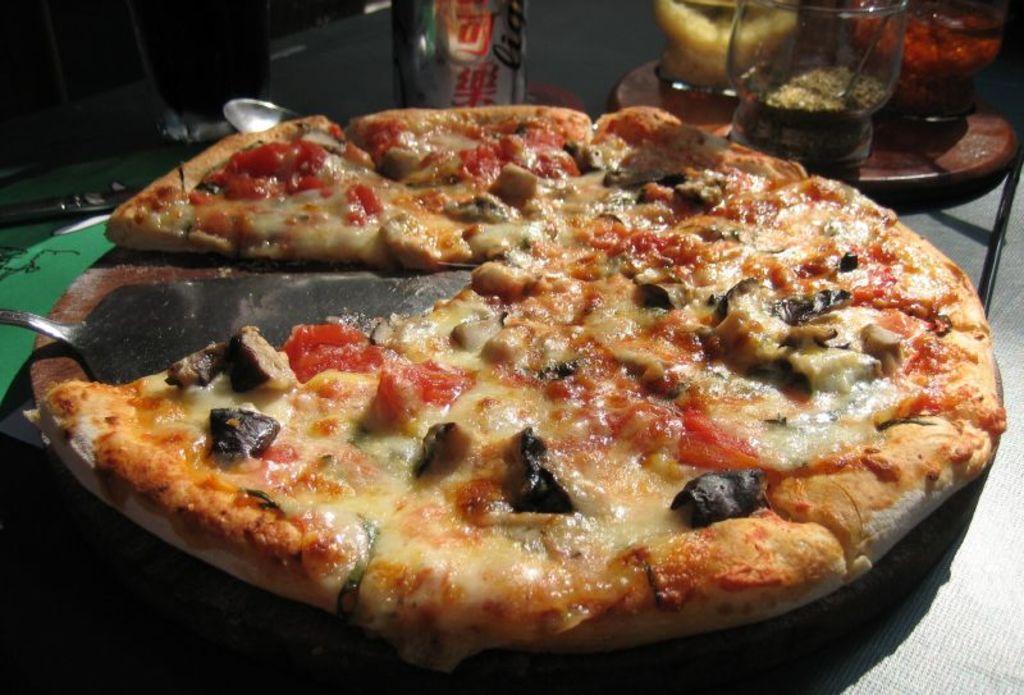Please provide a concise description of this image. In this image I can see a pizza and a spoon are placed on a wooden surface. At the top there are few objects in the dark. In the top right there is a table on which few glass objects are placed. 